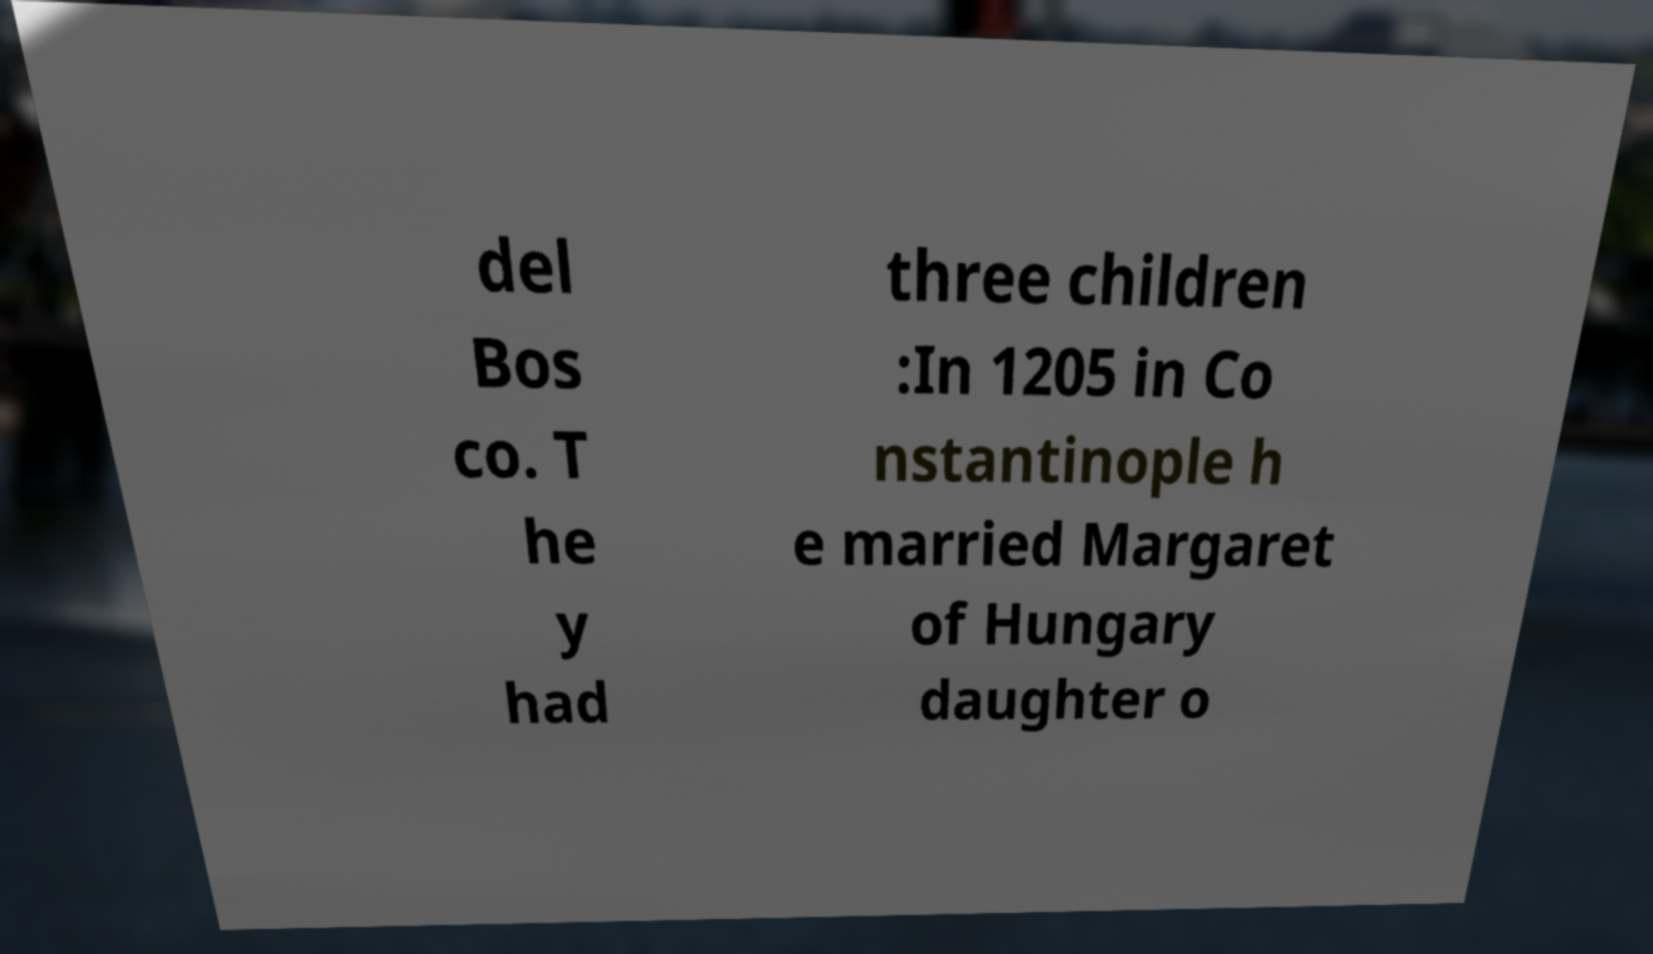I need the written content from this picture converted into text. Can you do that? del Bos co. T he y had three children :In 1205 in Co nstantinople h e married Margaret of Hungary daughter o 